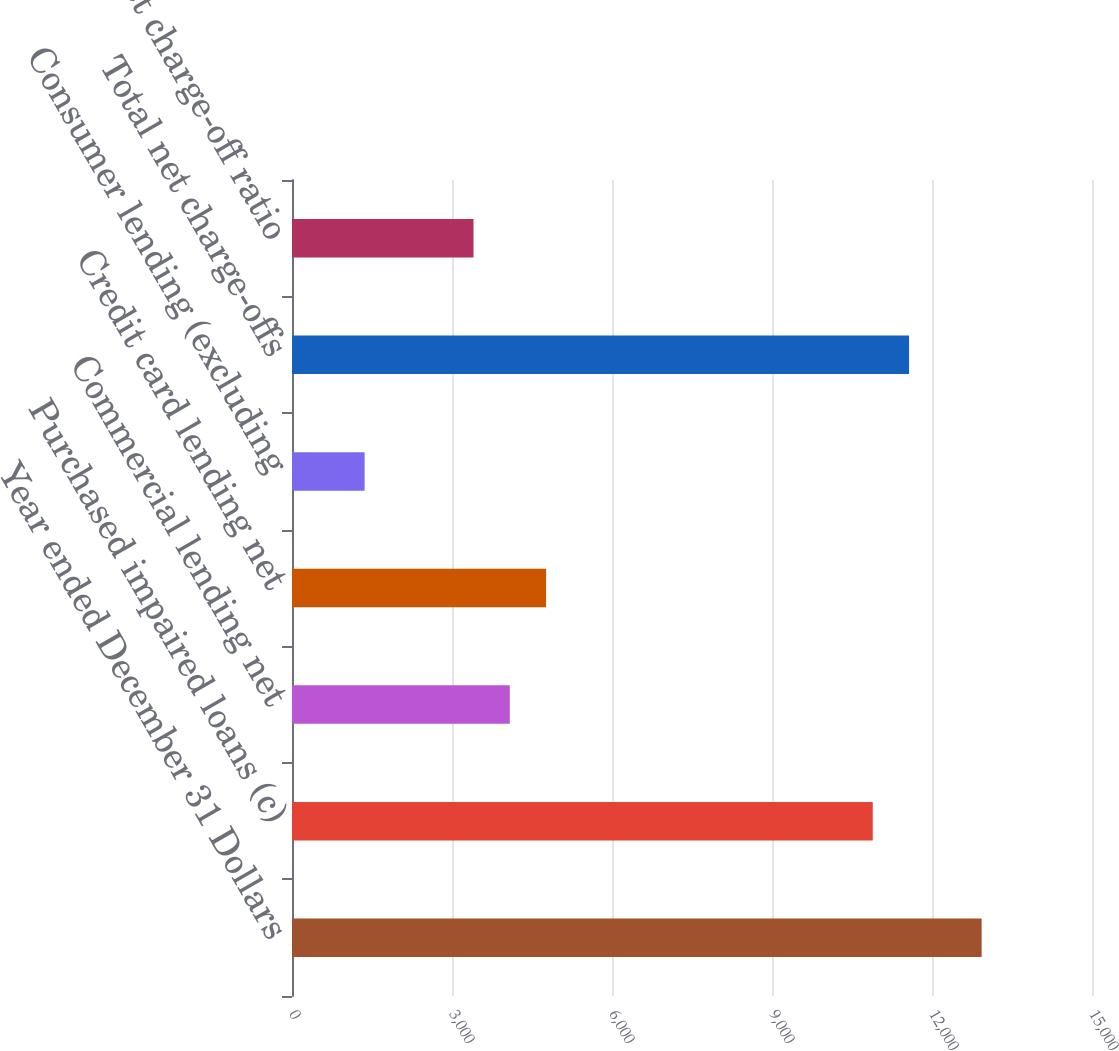<chart> <loc_0><loc_0><loc_500><loc_500><bar_chart><fcel>Year ended December 31 Dollars<fcel>Purchased impaired loans (c)<fcel>Commercial lending net<fcel>Credit card lending net<fcel>Consumer lending (excluding<fcel>Total net charge-offs<fcel>Total net charge-off ratio<nl><fcel>12931<fcel>10889.3<fcel>4083.74<fcel>4764.3<fcel>1361.5<fcel>11569.9<fcel>3403.18<nl></chart> 